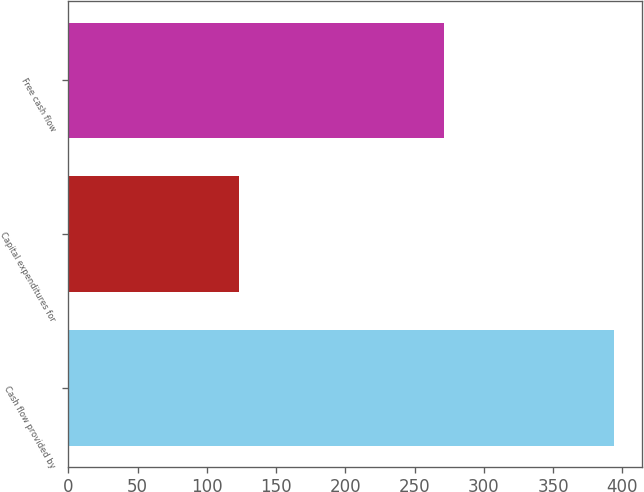Convert chart. <chart><loc_0><loc_0><loc_500><loc_500><bar_chart><fcel>Cash flow provided by<fcel>Capital expenditures for<fcel>Free cash flow<nl><fcel>394.2<fcel>122.8<fcel>271.4<nl></chart> 